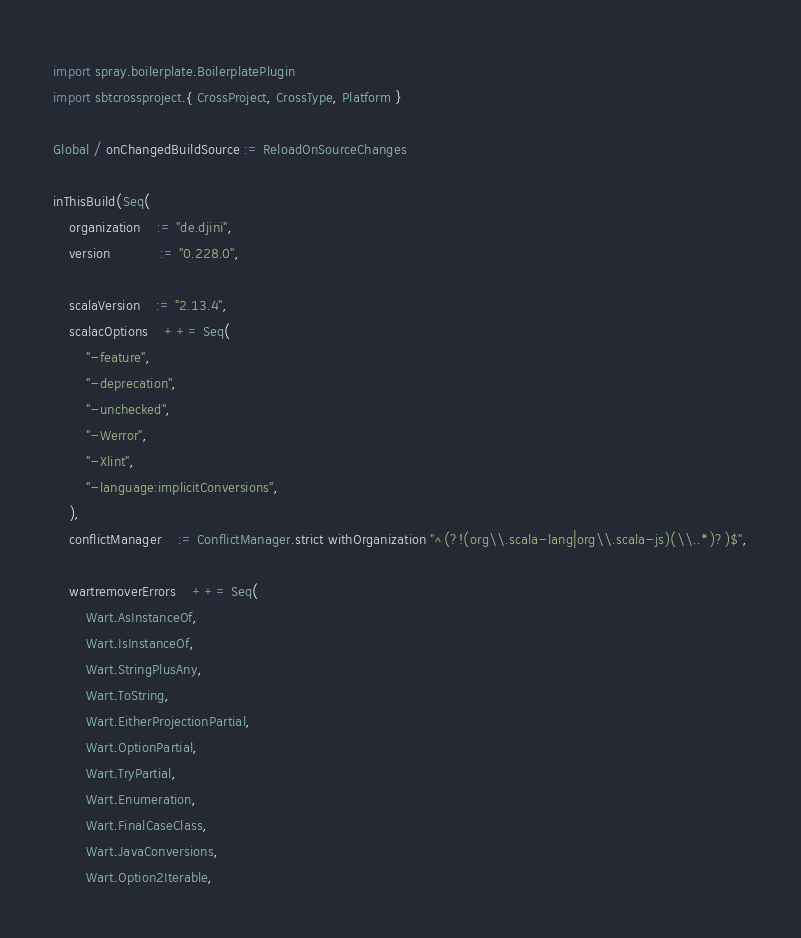<code> <loc_0><loc_0><loc_500><loc_500><_Scala_>import spray.boilerplate.BoilerplatePlugin
import sbtcrossproject.{ CrossProject, CrossType, Platform }

Global / onChangedBuildSource := ReloadOnSourceChanges

inThisBuild(Seq(
	organization	:= "de.djini",
	version			:= "0.228.0",

	scalaVersion	:= "2.13.4",
	scalacOptions	++= Seq(
		"-feature",
		"-deprecation",
		"-unchecked",
		"-Werror",
		"-Xlint",
		"-language:implicitConversions",
	),
	conflictManager	:= ConflictManager.strict withOrganization "^(?!(org\\.scala-lang|org\\.scala-js)(\\..*)?)$",

	wartremoverErrors	++= Seq(
		Wart.AsInstanceOf,
		Wart.IsInstanceOf,
		Wart.StringPlusAny,
		Wart.ToString,
		Wart.EitherProjectionPartial,
		Wart.OptionPartial,
		Wart.TryPartial,
		Wart.Enumeration,
		Wart.FinalCaseClass,
		Wart.JavaConversions,
		Wart.Option2Iterable,</code> 